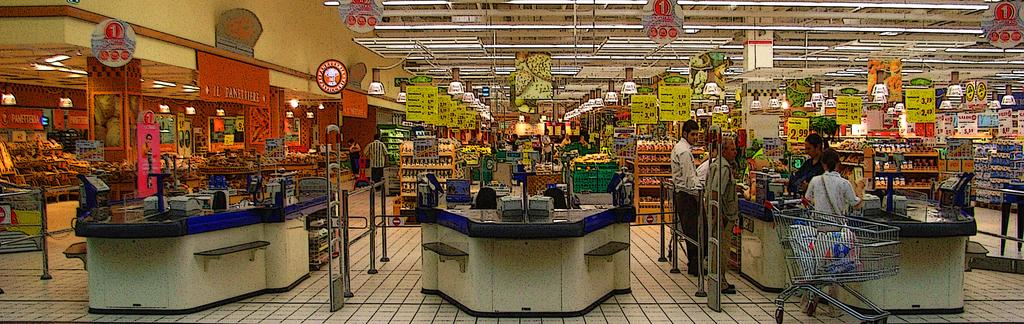What is the price on the sign nearest the cashier?
Your answer should be compact. 2.99. Which aisle number is the one on the far left?
Give a very brief answer. 1. 